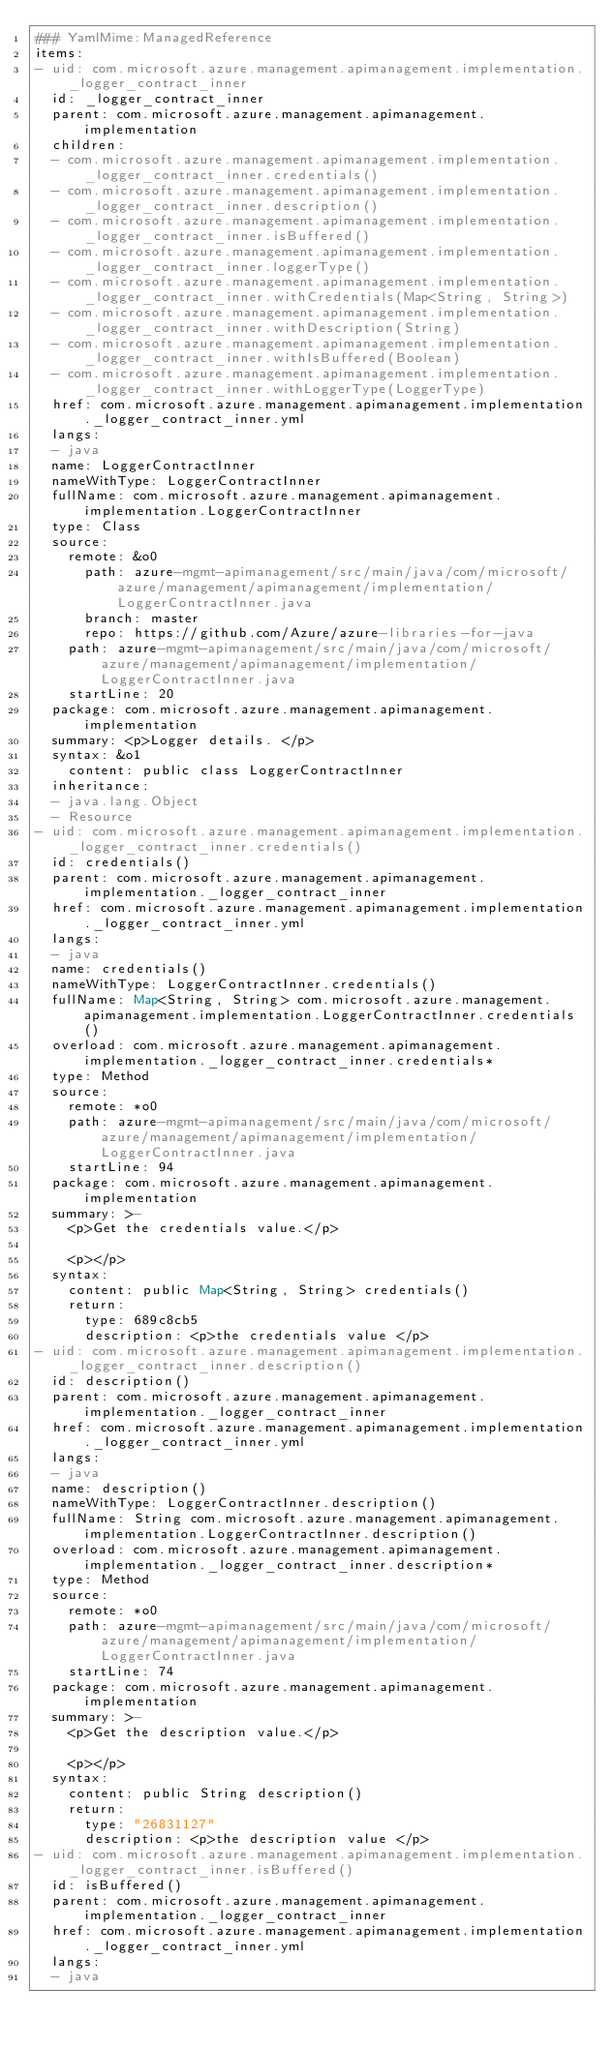<code> <loc_0><loc_0><loc_500><loc_500><_YAML_>### YamlMime:ManagedReference
items:
- uid: com.microsoft.azure.management.apimanagement.implementation._logger_contract_inner
  id: _logger_contract_inner
  parent: com.microsoft.azure.management.apimanagement.implementation
  children:
  - com.microsoft.azure.management.apimanagement.implementation._logger_contract_inner.credentials()
  - com.microsoft.azure.management.apimanagement.implementation._logger_contract_inner.description()
  - com.microsoft.azure.management.apimanagement.implementation._logger_contract_inner.isBuffered()
  - com.microsoft.azure.management.apimanagement.implementation._logger_contract_inner.loggerType()
  - com.microsoft.azure.management.apimanagement.implementation._logger_contract_inner.withCredentials(Map<String, String>)
  - com.microsoft.azure.management.apimanagement.implementation._logger_contract_inner.withDescription(String)
  - com.microsoft.azure.management.apimanagement.implementation._logger_contract_inner.withIsBuffered(Boolean)
  - com.microsoft.azure.management.apimanagement.implementation._logger_contract_inner.withLoggerType(LoggerType)
  href: com.microsoft.azure.management.apimanagement.implementation._logger_contract_inner.yml
  langs:
  - java
  name: LoggerContractInner
  nameWithType: LoggerContractInner
  fullName: com.microsoft.azure.management.apimanagement.implementation.LoggerContractInner
  type: Class
  source:
    remote: &o0
      path: azure-mgmt-apimanagement/src/main/java/com/microsoft/azure/management/apimanagement/implementation/LoggerContractInner.java
      branch: master
      repo: https://github.com/Azure/azure-libraries-for-java
    path: azure-mgmt-apimanagement/src/main/java/com/microsoft/azure/management/apimanagement/implementation/LoggerContractInner.java
    startLine: 20
  package: com.microsoft.azure.management.apimanagement.implementation
  summary: <p>Logger details. </p>
  syntax: &o1
    content: public class LoggerContractInner
  inheritance:
  - java.lang.Object
  - Resource
- uid: com.microsoft.azure.management.apimanagement.implementation._logger_contract_inner.credentials()
  id: credentials()
  parent: com.microsoft.azure.management.apimanagement.implementation._logger_contract_inner
  href: com.microsoft.azure.management.apimanagement.implementation._logger_contract_inner.yml
  langs:
  - java
  name: credentials()
  nameWithType: LoggerContractInner.credentials()
  fullName: Map<String, String> com.microsoft.azure.management.apimanagement.implementation.LoggerContractInner.credentials()
  overload: com.microsoft.azure.management.apimanagement.implementation._logger_contract_inner.credentials*
  type: Method
  source:
    remote: *o0
    path: azure-mgmt-apimanagement/src/main/java/com/microsoft/azure/management/apimanagement/implementation/LoggerContractInner.java
    startLine: 94
  package: com.microsoft.azure.management.apimanagement.implementation
  summary: >-
    <p>Get the credentials value.</p>

    <p></p>
  syntax:
    content: public Map<String, String> credentials()
    return:
      type: 689c8cb5
      description: <p>the credentials value </p>
- uid: com.microsoft.azure.management.apimanagement.implementation._logger_contract_inner.description()
  id: description()
  parent: com.microsoft.azure.management.apimanagement.implementation._logger_contract_inner
  href: com.microsoft.azure.management.apimanagement.implementation._logger_contract_inner.yml
  langs:
  - java
  name: description()
  nameWithType: LoggerContractInner.description()
  fullName: String com.microsoft.azure.management.apimanagement.implementation.LoggerContractInner.description()
  overload: com.microsoft.azure.management.apimanagement.implementation._logger_contract_inner.description*
  type: Method
  source:
    remote: *o0
    path: azure-mgmt-apimanagement/src/main/java/com/microsoft/azure/management/apimanagement/implementation/LoggerContractInner.java
    startLine: 74
  package: com.microsoft.azure.management.apimanagement.implementation
  summary: >-
    <p>Get the description value.</p>

    <p></p>
  syntax:
    content: public String description()
    return:
      type: "26831127"
      description: <p>the description value </p>
- uid: com.microsoft.azure.management.apimanagement.implementation._logger_contract_inner.isBuffered()
  id: isBuffered()
  parent: com.microsoft.azure.management.apimanagement.implementation._logger_contract_inner
  href: com.microsoft.azure.management.apimanagement.implementation._logger_contract_inner.yml
  langs:
  - java</code> 